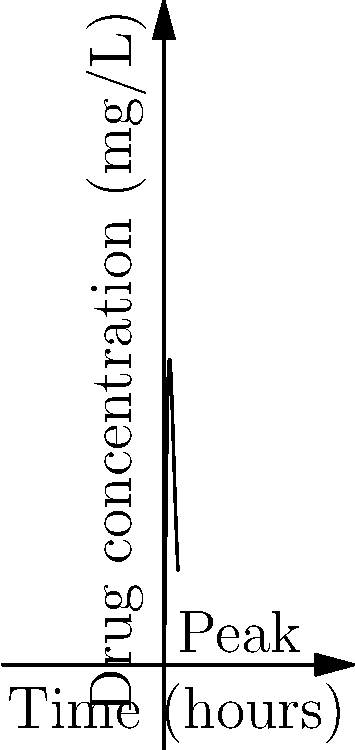A new drug's concentration in the bloodstream over time can be modeled by the function $C(t) = 100t^2e^{-0.5t}$, where $C$ is the concentration in mg/L and $t$ is the time in hours after administration. At what time does the drug concentration reach its peak? To find the peak concentration, we need to determine when the derivative of the function equals zero:

1) First, let's calculate the derivative of $C(t)$ using the product rule:
   $C'(t) = 100(2te^{-0.5t} + t^2(-0.5e^{-0.5t}))$
   $C'(t) = 100e^{-0.5t}(2t - 0.5t^2)$

2) Set the derivative equal to zero:
   $100e^{-0.5t}(2t - 0.5t^2) = 0$

3) The exponential term is always positive, so we can focus on:
   $2t - 0.5t^2 = 0$

4) Factor out t:
   $t(2 - 0.5t) = 0$

5) Solve the equation:
   $t = 0$ or $2 - 0.5t = 0$
   $t = 0$ or $t = 4$

6) $t = 0$ gives the minimum (initial concentration), so $t = 4$ must be the peak.

7) Verify by checking the second derivative is negative at $t = 4$.

Therefore, the drug concentration reaches its peak 4 hours after administration.
Answer: 4 hours 